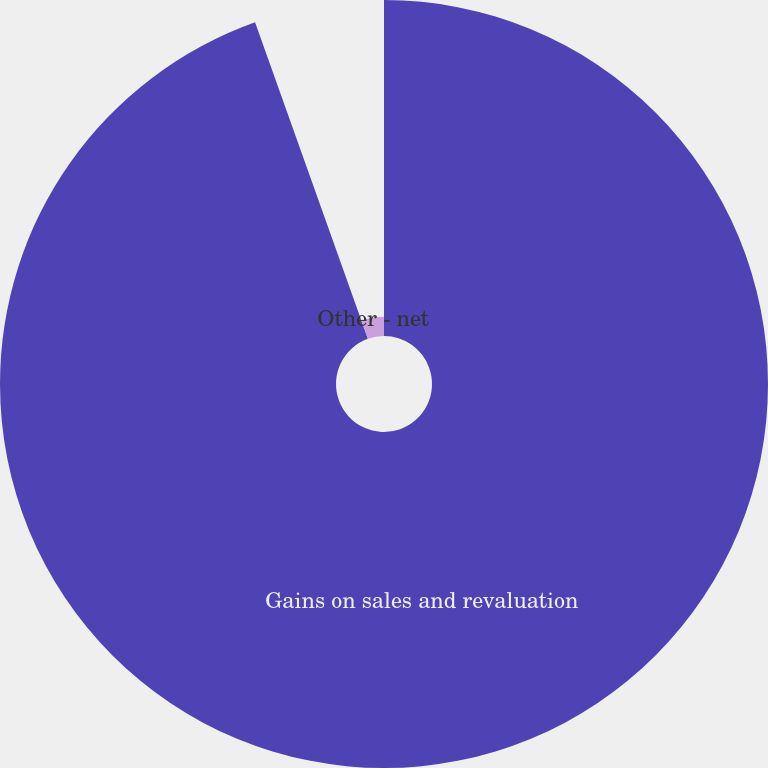Convert chart. <chart><loc_0><loc_0><loc_500><loc_500><pie_chart><fcel>Gains on sales and revaluation<fcel>Other - net<nl><fcel>94.55%<fcel>5.45%<nl></chart> 